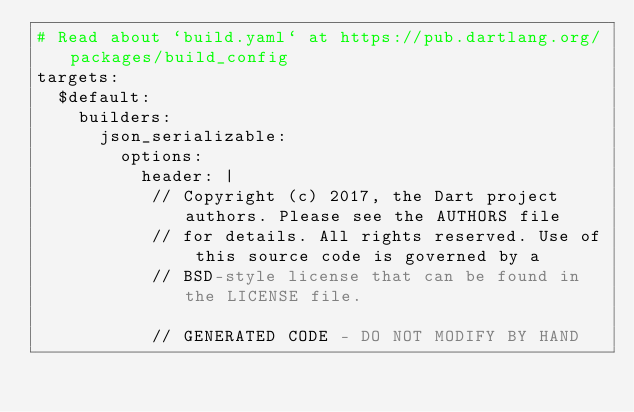Convert code to text. <code><loc_0><loc_0><loc_500><loc_500><_YAML_># Read about `build.yaml` at https://pub.dartlang.org/packages/build_config
targets:
  $default:
    builders:
      json_serializable:
        options:
          header: |
           // Copyright (c) 2017, the Dart project authors. Please see the AUTHORS file
           // for details. All rights reserved. Use of this source code is governed by a
           // BSD-style license that can be found in the LICENSE file.

           // GENERATED CODE - DO NOT MODIFY BY HAND</code> 